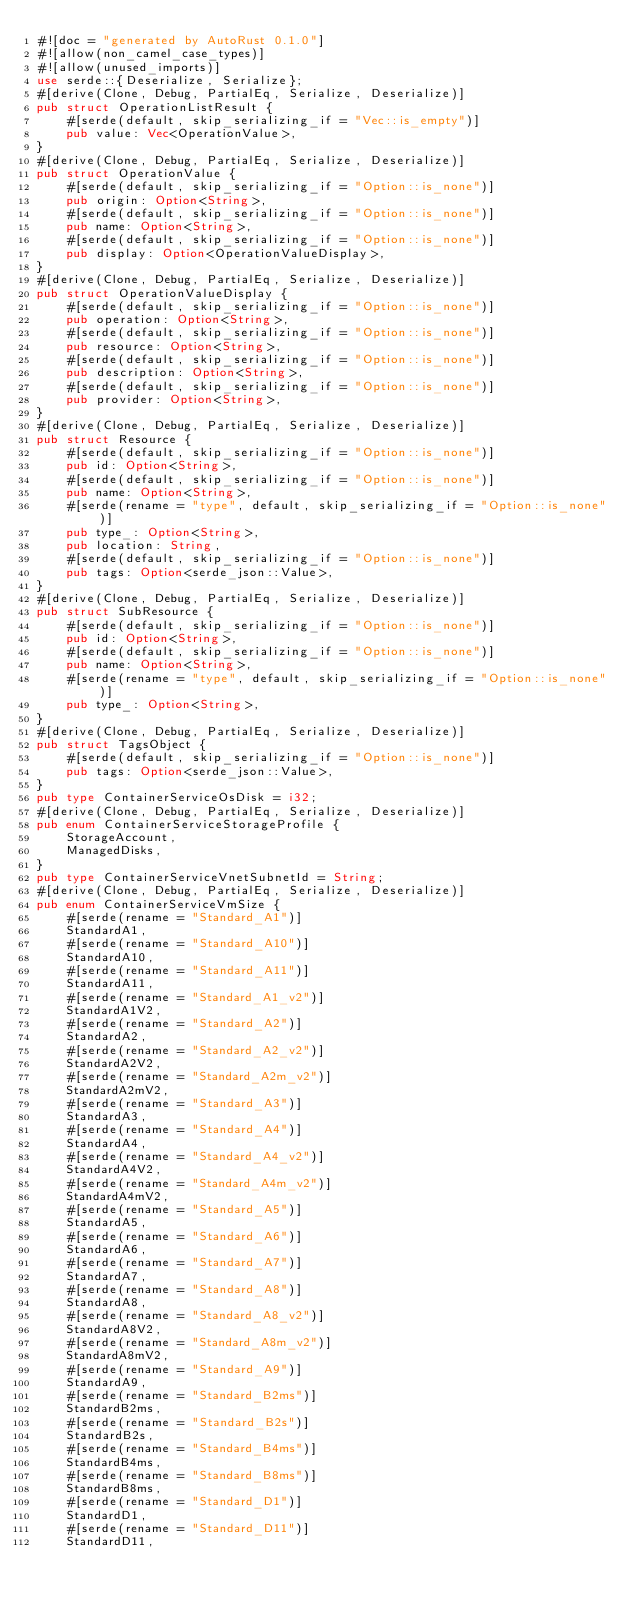<code> <loc_0><loc_0><loc_500><loc_500><_Rust_>#![doc = "generated by AutoRust 0.1.0"]
#![allow(non_camel_case_types)]
#![allow(unused_imports)]
use serde::{Deserialize, Serialize};
#[derive(Clone, Debug, PartialEq, Serialize, Deserialize)]
pub struct OperationListResult {
    #[serde(default, skip_serializing_if = "Vec::is_empty")]
    pub value: Vec<OperationValue>,
}
#[derive(Clone, Debug, PartialEq, Serialize, Deserialize)]
pub struct OperationValue {
    #[serde(default, skip_serializing_if = "Option::is_none")]
    pub origin: Option<String>,
    #[serde(default, skip_serializing_if = "Option::is_none")]
    pub name: Option<String>,
    #[serde(default, skip_serializing_if = "Option::is_none")]
    pub display: Option<OperationValueDisplay>,
}
#[derive(Clone, Debug, PartialEq, Serialize, Deserialize)]
pub struct OperationValueDisplay {
    #[serde(default, skip_serializing_if = "Option::is_none")]
    pub operation: Option<String>,
    #[serde(default, skip_serializing_if = "Option::is_none")]
    pub resource: Option<String>,
    #[serde(default, skip_serializing_if = "Option::is_none")]
    pub description: Option<String>,
    #[serde(default, skip_serializing_if = "Option::is_none")]
    pub provider: Option<String>,
}
#[derive(Clone, Debug, PartialEq, Serialize, Deserialize)]
pub struct Resource {
    #[serde(default, skip_serializing_if = "Option::is_none")]
    pub id: Option<String>,
    #[serde(default, skip_serializing_if = "Option::is_none")]
    pub name: Option<String>,
    #[serde(rename = "type", default, skip_serializing_if = "Option::is_none")]
    pub type_: Option<String>,
    pub location: String,
    #[serde(default, skip_serializing_if = "Option::is_none")]
    pub tags: Option<serde_json::Value>,
}
#[derive(Clone, Debug, PartialEq, Serialize, Deserialize)]
pub struct SubResource {
    #[serde(default, skip_serializing_if = "Option::is_none")]
    pub id: Option<String>,
    #[serde(default, skip_serializing_if = "Option::is_none")]
    pub name: Option<String>,
    #[serde(rename = "type", default, skip_serializing_if = "Option::is_none")]
    pub type_: Option<String>,
}
#[derive(Clone, Debug, PartialEq, Serialize, Deserialize)]
pub struct TagsObject {
    #[serde(default, skip_serializing_if = "Option::is_none")]
    pub tags: Option<serde_json::Value>,
}
pub type ContainerServiceOsDisk = i32;
#[derive(Clone, Debug, PartialEq, Serialize, Deserialize)]
pub enum ContainerServiceStorageProfile {
    StorageAccount,
    ManagedDisks,
}
pub type ContainerServiceVnetSubnetId = String;
#[derive(Clone, Debug, PartialEq, Serialize, Deserialize)]
pub enum ContainerServiceVmSize {
    #[serde(rename = "Standard_A1")]
    StandardA1,
    #[serde(rename = "Standard_A10")]
    StandardA10,
    #[serde(rename = "Standard_A11")]
    StandardA11,
    #[serde(rename = "Standard_A1_v2")]
    StandardA1V2,
    #[serde(rename = "Standard_A2")]
    StandardA2,
    #[serde(rename = "Standard_A2_v2")]
    StandardA2V2,
    #[serde(rename = "Standard_A2m_v2")]
    StandardA2mV2,
    #[serde(rename = "Standard_A3")]
    StandardA3,
    #[serde(rename = "Standard_A4")]
    StandardA4,
    #[serde(rename = "Standard_A4_v2")]
    StandardA4V2,
    #[serde(rename = "Standard_A4m_v2")]
    StandardA4mV2,
    #[serde(rename = "Standard_A5")]
    StandardA5,
    #[serde(rename = "Standard_A6")]
    StandardA6,
    #[serde(rename = "Standard_A7")]
    StandardA7,
    #[serde(rename = "Standard_A8")]
    StandardA8,
    #[serde(rename = "Standard_A8_v2")]
    StandardA8V2,
    #[serde(rename = "Standard_A8m_v2")]
    StandardA8mV2,
    #[serde(rename = "Standard_A9")]
    StandardA9,
    #[serde(rename = "Standard_B2ms")]
    StandardB2ms,
    #[serde(rename = "Standard_B2s")]
    StandardB2s,
    #[serde(rename = "Standard_B4ms")]
    StandardB4ms,
    #[serde(rename = "Standard_B8ms")]
    StandardB8ms,
    #[serde(rename = "Standard_D1")]
    StandardD1,
    #[serde(rename = "Standard_D11")]
    StandardD11,</code> 